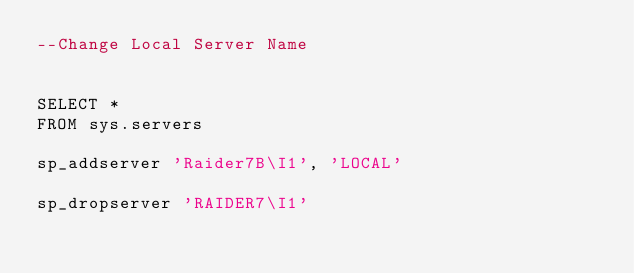Convert code to text. <code><loc_0><loc_0><loc_500><loc_500><_SQL_>--Change Local Server Name


SELECT *
FROM sys.servers

sp_addserver 'Raider7B\I1', 'LOCAL'

sp_dropserver 'RAIDER7\I1'</code> 